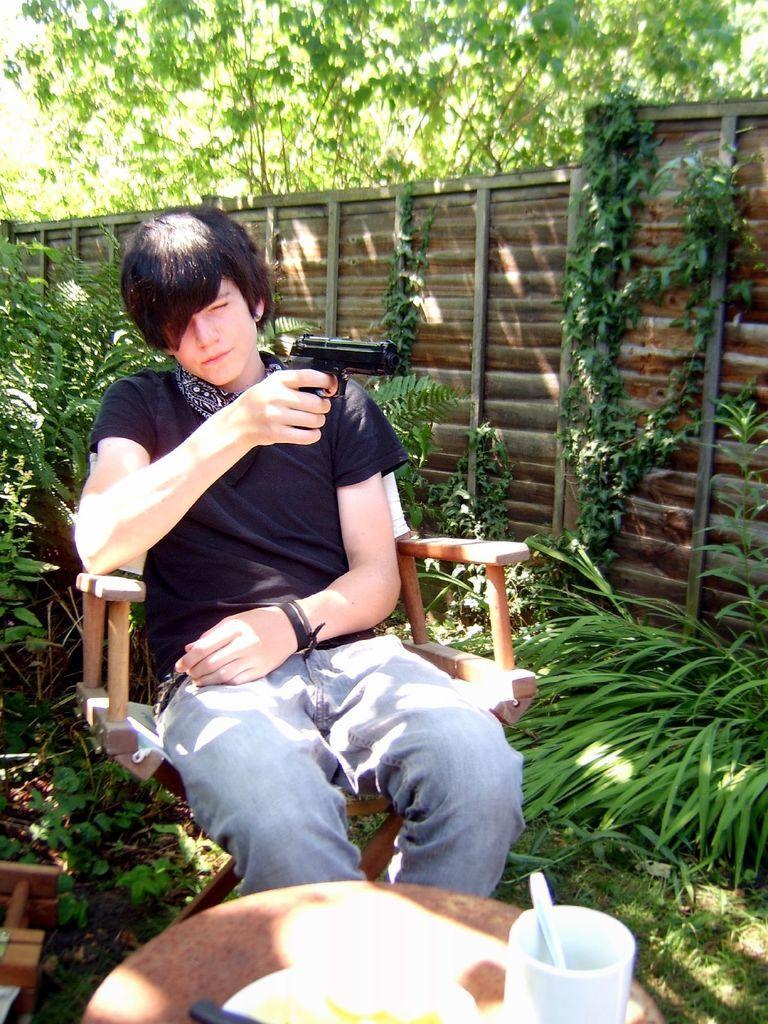Describe this image in one or two sentences. On the background we can see trees and wooden board in the form of a wall. These are plants. Here we can see a man wearing black shirt sitting on a chair and he is holding a gun his hand. On the table table we can see a mug, spoon and a plate. 